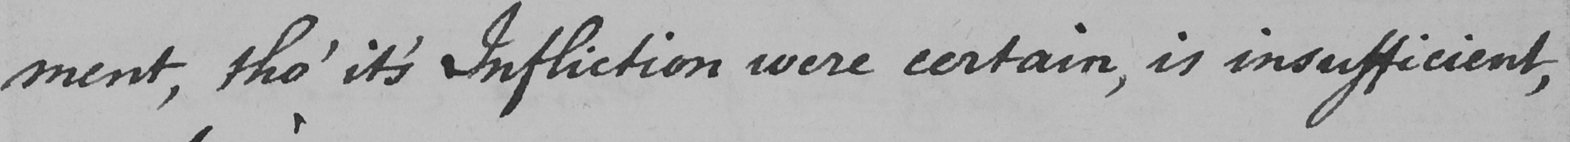What text is written in this handwritten line? -ment , tho '  it ' s Infliction were certain , is insufficient , 